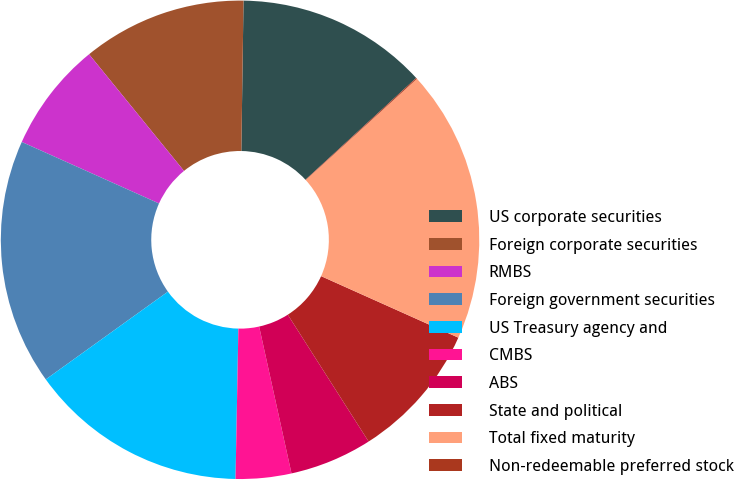Convert chart. <chart><loc_0><loc_0><loc_500><loc_500><pie_chart><fcel>US corporate securities<fcel>Foreign corporate securities<fcel>RMBS<fcel>Foreign government securities<fcel>US Treasury agency and<fcel>CMBS<fcel>ABS<fcel>State and political<fcel>Total fixed maturity<fcel>Non-redeemable preferred stock<nl><fcel>12.94%<fcel>11.1%<fcel>7.42%<fcel>16.62%<fcel>14.78%<fcel>3.75%<fcel>5.58%<fcel>9.26%<fcel>18.46%<fcel>0.07%<nl></chart> 